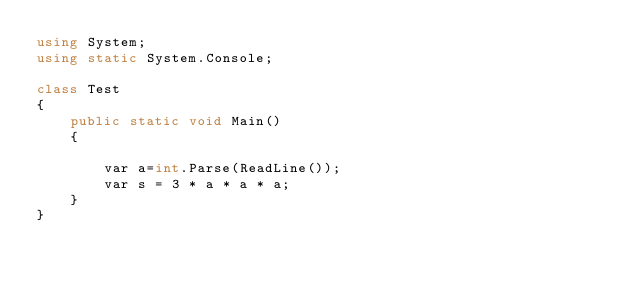Convert code to text. <code><loc_0><loc_0><loc_500><loc_500><_C#_>using System;
using static System.Console;

class Test
{
    public static void Main()
    {
        
        var a=int.Parse(ReadLine());
        var s = 3 * a * a * a;
    }
}</code> 